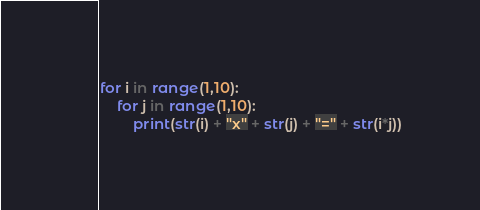Convert code to text. <code><loc_0><loc_0><loc_500><loc_500><_Python_>for i in range(1,10):
    for j in range(1,10):
        print(str(i) + "x" + str(j) + "=" + str(i*j))
</code> 